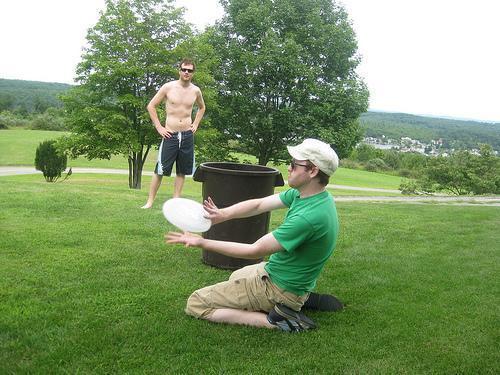How many people are there?
Give a very brief answer. 2. 